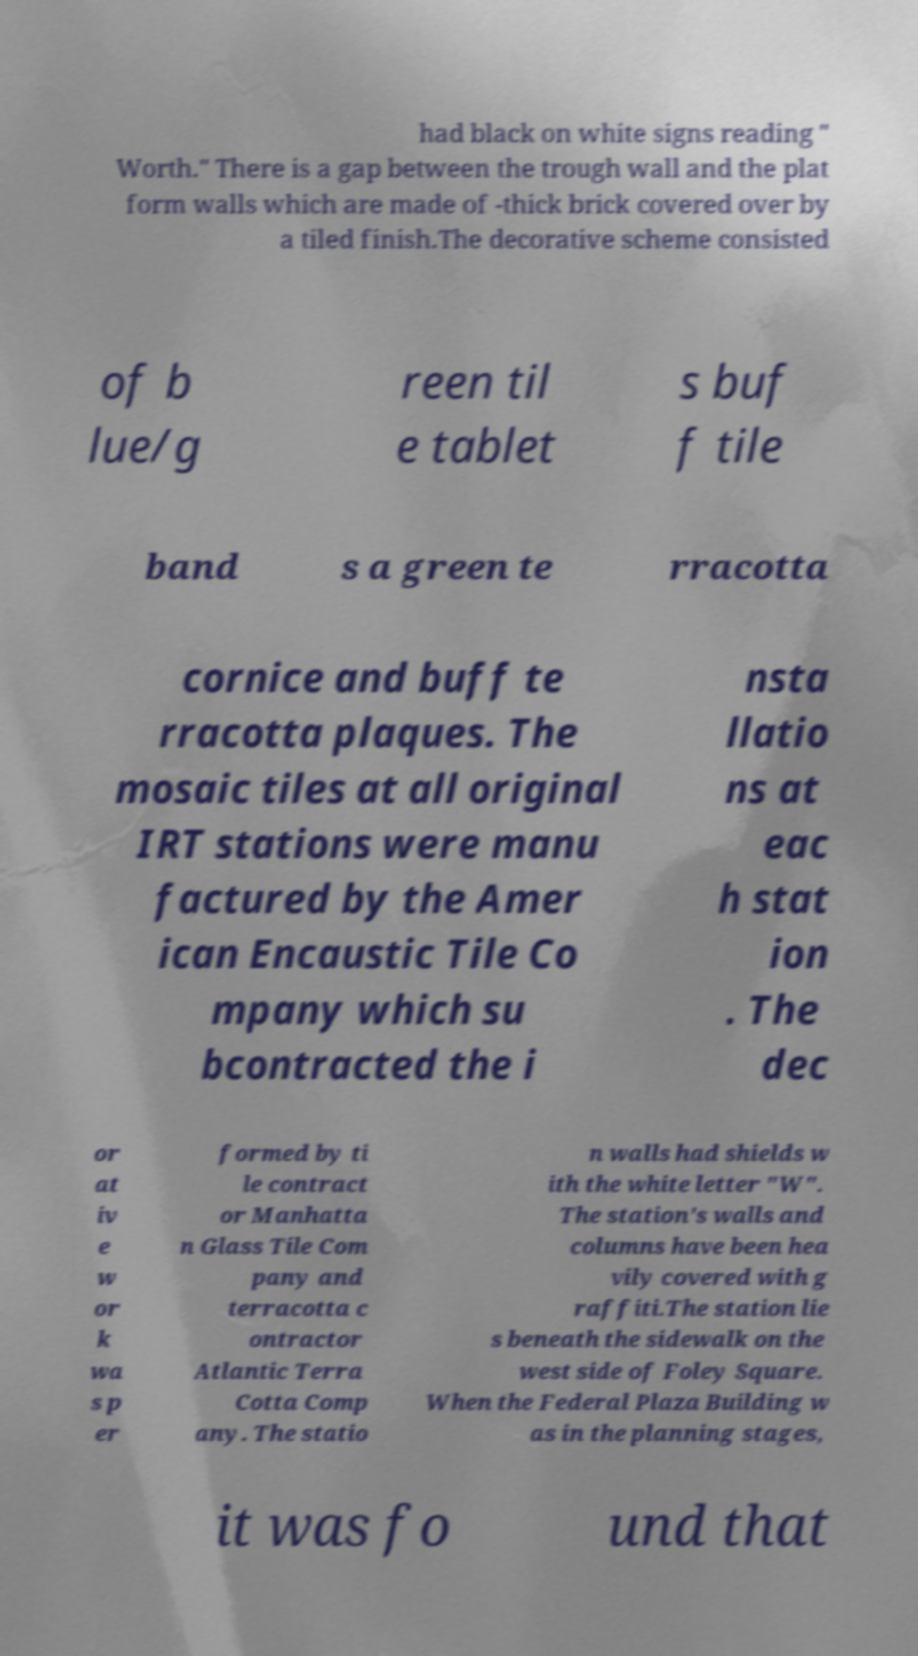I need the written content from this picture converted into text. Can you do that? had black on white signs reading " Worth." There is a gap between the trough wall and the plat form walls which are made of -thick brick covered over by a tiled finish.The decorative scheme consisted of b lue/g reen til e tablet s buf f tile band s a green te rracotta cornice and buff te rracotta plaques. The mosaic tiles at all original IRT stations were manu factured by the Amer ican Encaustic Tile Co mpany which su bcontracted the i nsta llatio ns at eac h stat ion . The dec or at iv e w or k wa s p er formed by ti le contract or Manhatta n Glass Tile Com pany and terracotta c ontractor Atlantic Terra Cotta Comp any. The statio n walls had shields w ith the white letter "W". The station's walls and columns have been hea vily covered with g raffiti.The station lie s beneath the sidewalk on the west side of Foley Square. When the Federal Plaza Building w as in the planning stages, it was fo und that 